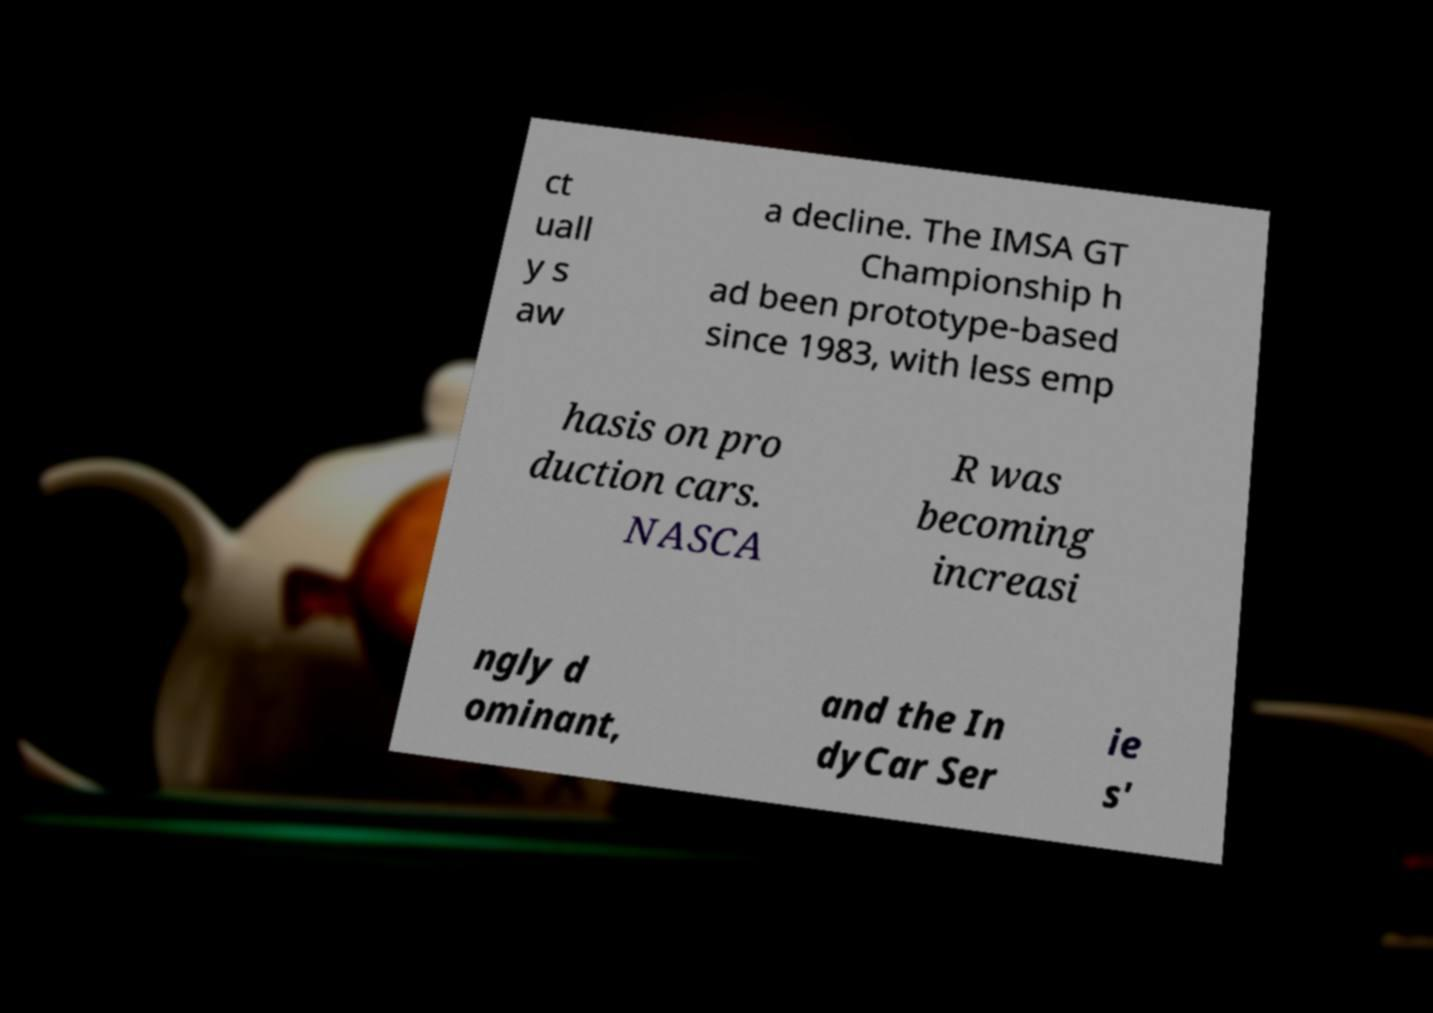Please identify and transcribe the text found in this image. ct uall y s aw a decline. The IMSA GT Championship h ad been prototype-based since 1983, with less emp hasis on pro duction cars. NASCA R was becoming increasi ngly d ominant, and the In dyCar Ser ie s' 